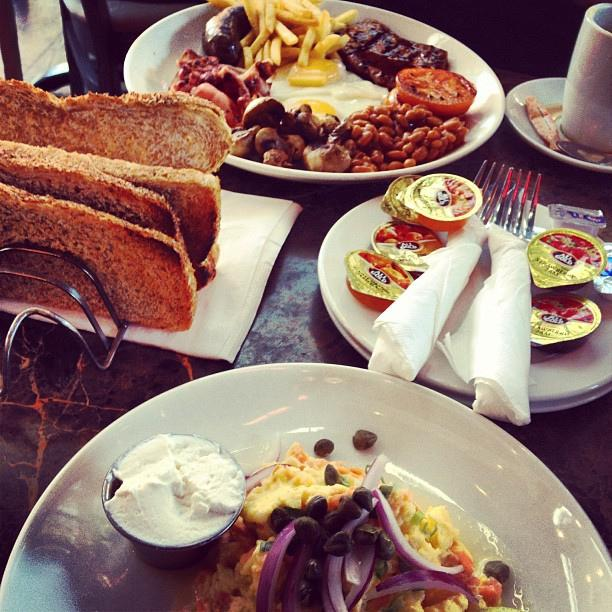What is on the plate with the two wrapped forks? Please explain your reasoning. butter jelly. The plate has butter and jelly. 